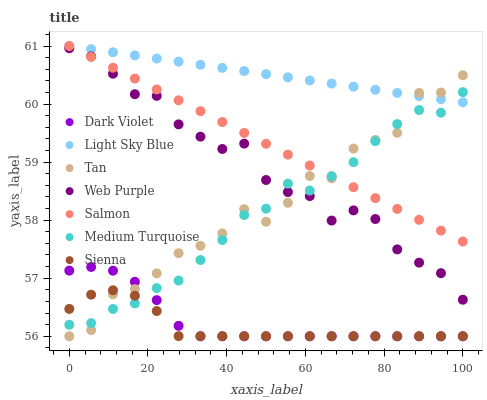Does Sienna have the minimum area under the curve?
Answer yes or no. Yes. Does Light Sky Blue have the maximum area under the curve?
Answer yes or no. Yes. Does Dark Violet have the minimum area under the curve?
Answer yes or no. No. Does Dark Violet have the maximum area under the curve?
Answer yes or no. No. Is Salmon the smoothest?
Answer yes or no. Yes. Is Tan the roughest?
Answer yes or no. Yes. Is Dark Violet the smoothest?
Answer yes or no. No. Is Dark Violet the roughest?
Answer yes or no. No. Does Dark Violet have the lowest value?
Answer yes or no. Yes. Does Web Purple have the lowest value?
Answer yes or no. No. Does Light Sky Blue have the highest value?
Answer yes or no. Yes. Does Dark Violet have the highest value?
Answer yes or no. No. Is Dark Violet less than Web Purple?
Answer yes or no. Yes. Is Salmon greater than Sienna?
Answer yes or no. Yes. Does Salmon intersect Light Sky Blue?
Answer yes or no. Yes. Is Salmon less than Light Sky Blue?
Answer yes or no. No. Is Salmon greater than Light Sky Blue?
Answer yes or no. No. Does Dark Violet intersect Web Purple?
Answer yes or no. No. 